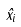<formula> <loc_0><loc_0><loc_500><loc_500>\hat { x } _ { i }</formula> 